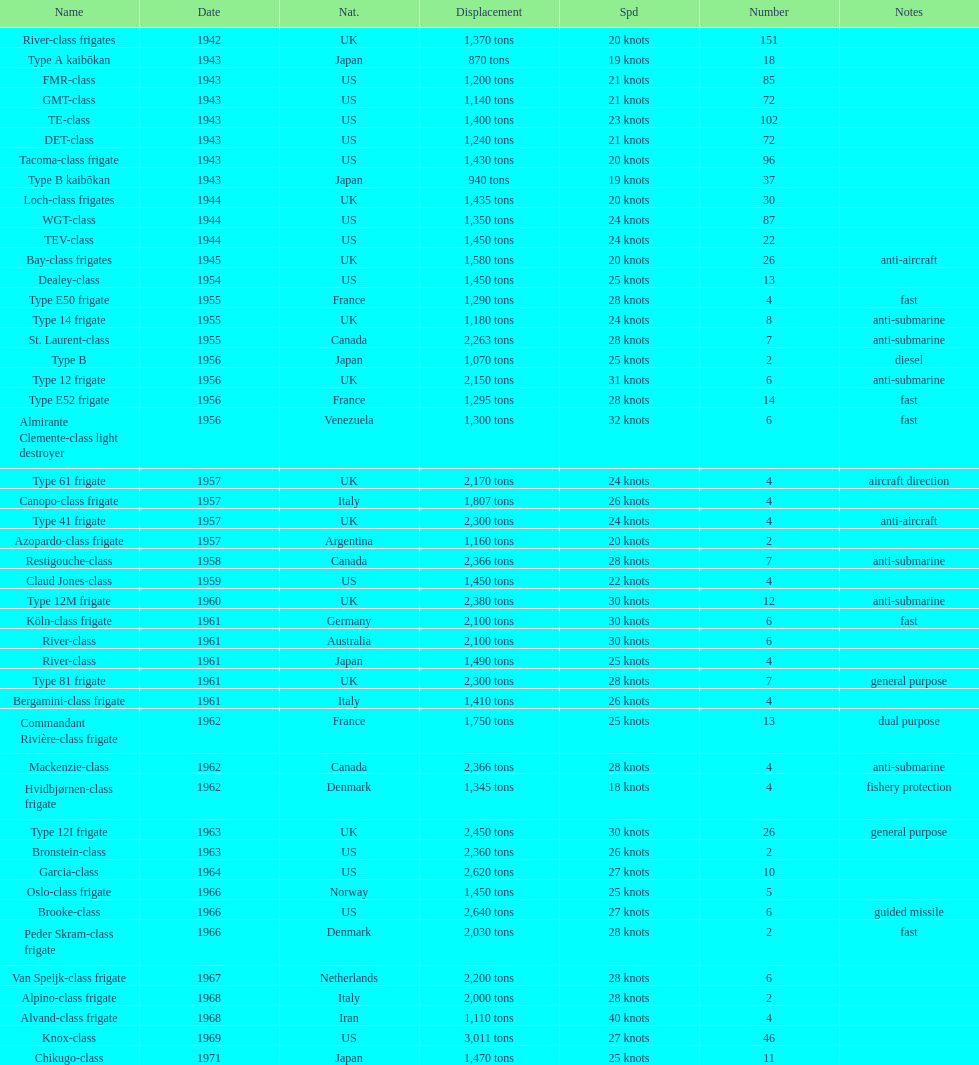Which name has the largest displacement? Knox-class. 